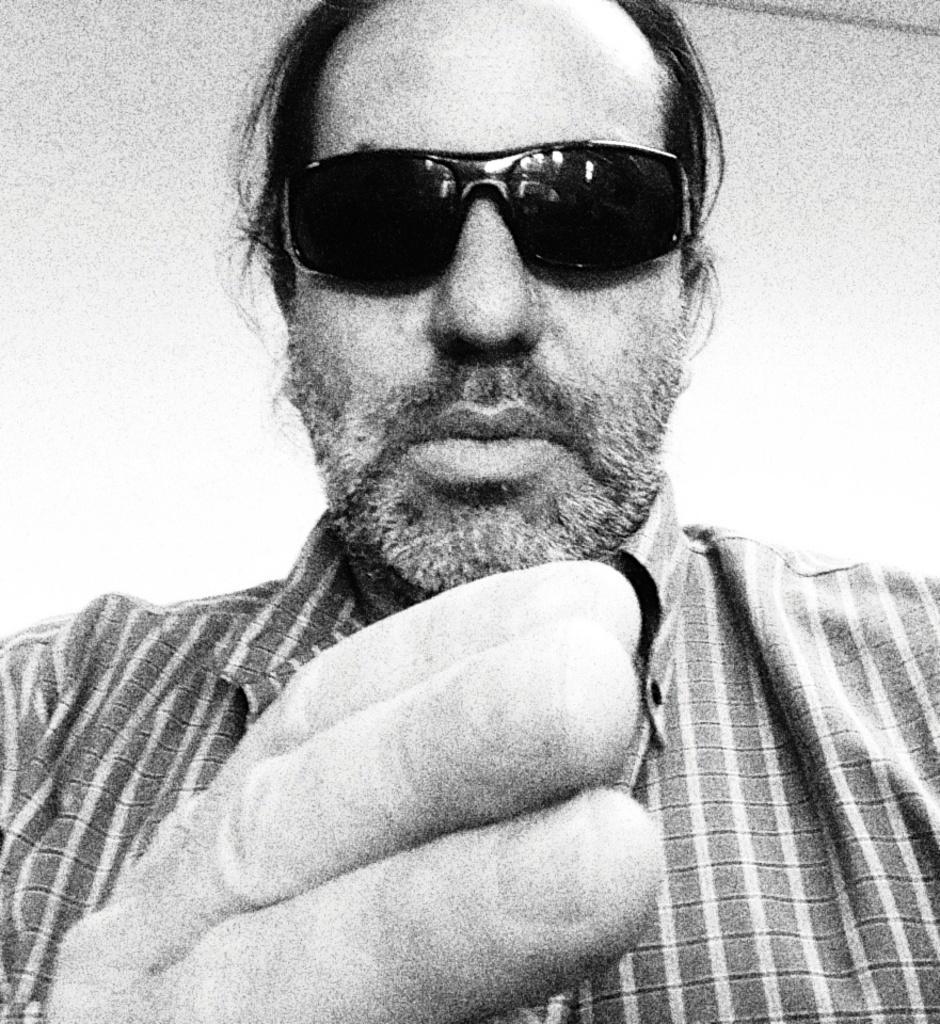Could you give a brief overview of what you see in this image? In this black and white picture there is a man. He is wearing sunglasses. 